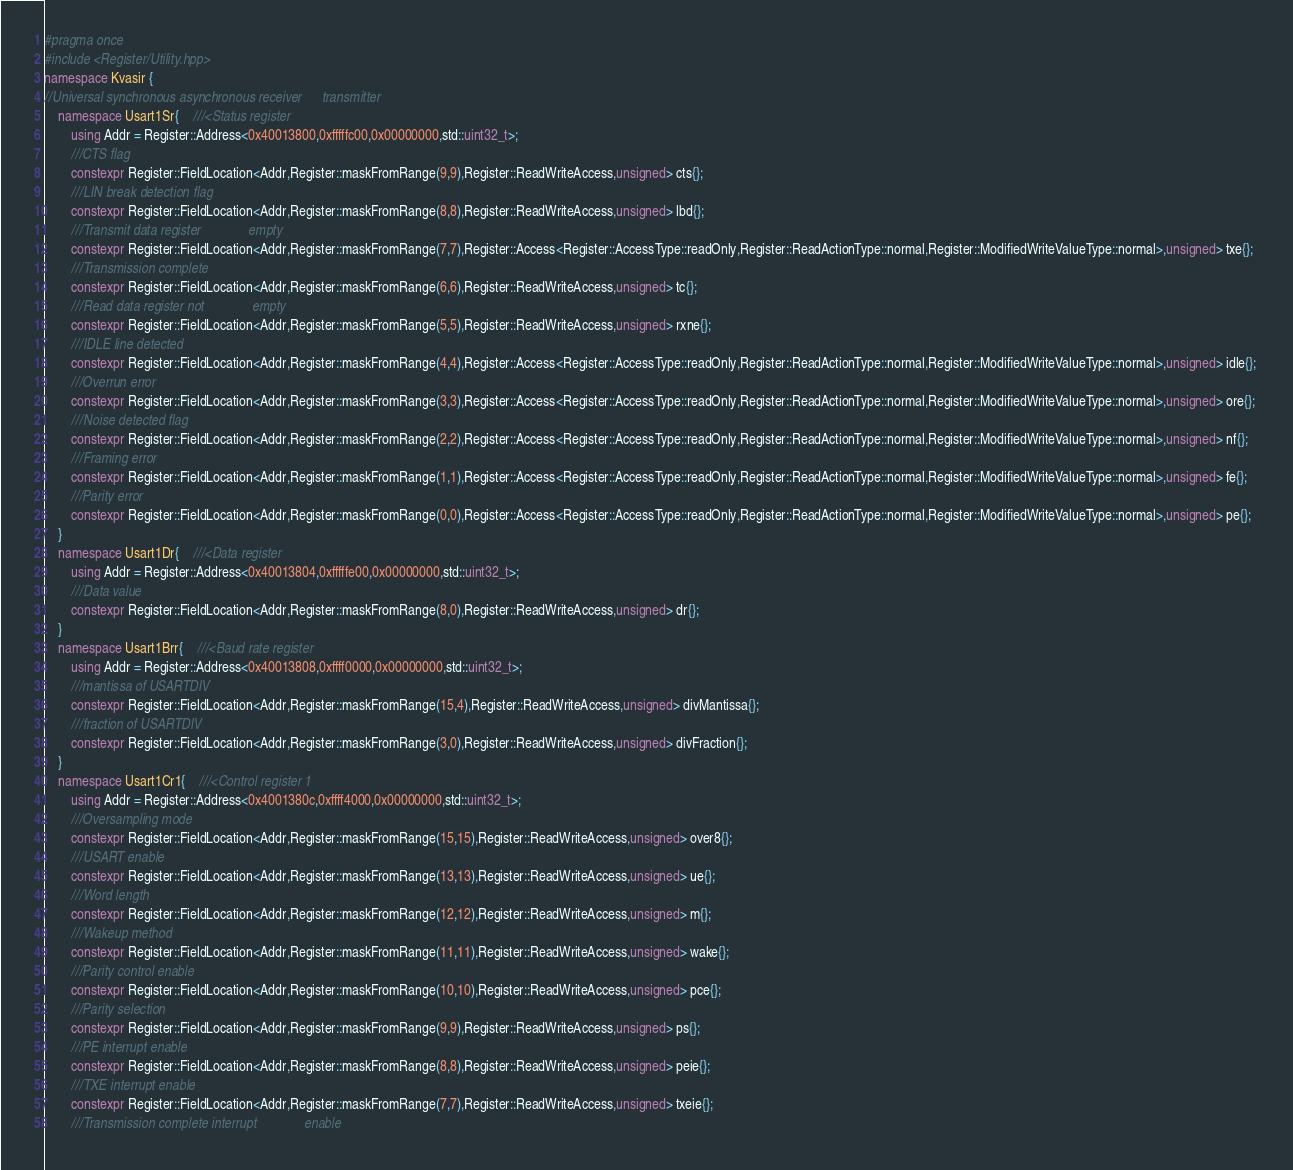Convert code to text. <code><loc_0><loc_0><loc_500><loc_500><_C++_>#pragma once 
#include <Register/Utility.hpp>
namespace Kvasir {
//Universal synchronous asynchronous receiver      transmitter
    namespace Usart1Sr{    ///<Status register
        using Addr = Register::Address<0x40013800,0xfffffc00,0x00000000,std::uint32_t>;
        ///CTS flag
        constexpr Register::FieldLocation<Addr,Register::maskFromRange(9,9),Register::ReadWriteAccess,unsigned> cts{}; 
        ///LIN break detection flag
        constexpr Register::FieldLocation<Addr,Register::maskFromRange(8,8),Register::ReadWriteAccess,unsigned> lbd{}; 
        ///Transmit data register              empty
        constexpr Register::FieldLocation<Addr,Register::maskFromRange(7,7),Register::Access<Register::AccessType::readOnly,Register::ReadActionType::normal,Register::ModifiedWriteValueType::normal>,unsigned> txe{}; 
        ///Transmission complete
        constexpr Register::FieldLocation<Addr,Register::maskFromRange(6,6),Register::ReadWriteAccess,unsigned> tc{}; 
        ///Read data register not              empty
        constexpr Register::FieldLocation<Addr,Register::maskFromRange(5,5),Register::ReadWriteAccess,unsigned> rxne{}; 
        ///IDLE line detected
        constexpr Register::FieldLocation<Addr,Register::maskFromRange(4,4),Register::Access<Register::AccessType::readOnly,Register::ReadActionType::normal,Register::ModifiedWriteValueType::normal>,unsigned> idle{}; 
        ///Overrun error
        constexpr Register::FieldLocation<Addr,Register::maskFromRange(3,3),Register::Access<Register::AccessType::readOnly,Register::ReadActionType::normal,Register::ModifiedWriteValueType::normal>,unsigned> ore{}; 
        ///Noise detected flag
        constexpr Register::FieldLocation<Addr,Register::maskFromRange(2,2),Register::Access<Register::AccessType::readOnly,Register::ReadActionType::normal,Register::ModifiedWriteValueType::normal>,unsigned> nf{}; 
        ///Framing error
        constexpr Register::FieldLocation<Addr,Register::maskFromRange(1,1),Register::Access<Register::AccessType::readOnly,Register::ReadActionType::normal,Register::ModifiedWriteValueType::normal>,unsigned> fe{}; 
        ///Parity error
        constexpr Register::FieldLocation<Addr,Register::maskFromRange(0,0),Register::Access<Register::AccessType::readOnly,Register::ReadActionType::normal,Register::ModifiedWriteValueType::normal>,unsigned> pe{}; 
    }
    namespace Usart1Dr{    ///<Data register
        using Addr = Register::Address<0x40013804,0xfffffe00,0x00000000,std::uint32_t>;
        ///Data value
        constexpr Register::FieldLocation<Addr,Register::maskFromRange(8,0),Register::ReadWriteAccess,unsigned> dr{}; 
    }
    namespace Usart1Brr{    ///<Baud rate register
        using Addr = Register::Address<0x40013808,0xffff0000,0x00000000,std::uint32_t>;
        ///mantissa of USARTDIV
        constexpr Register::FieldLocation<Addr,Register::maskFromRange(15,4),Register::ReadWriteAccess,unsigned> divMantissa{}; 
        ///fraction of USARTDIV
        constexpr Register::FieldLocation<Addr,Register::maskFromRange(3,0),Register::ReadWriteAccess,unsigned> divFraction{}; 
    }
    namespace Usart1Cr1{    ///<Control register 1
        using Addr = Register::Address<0x4001380c,0xffff4000,0x00000000,std::uint32_t>;
        ///Oversampling mode
        constexpr Register::FieldLocation<Addr,Register::maskFromRange(15,15),Register::ReadWriteAccess,unsigned> over8{}; 
        ///USART enable
        constexpr Register::FieldLocation<Addr,Register::maskFromRange(13,13),Register::ReadWriteAccess,unsigned> ue{}; 
        ///Word length
        constexpr Register::FieldLocation<Addr,Register::maskFromRange(12,12),Register::ReadWriteAccess,unsigned> m{}; 
        ///Wakeup method
        constexpr Register::FieldLocation<Addr,Register::maskFromRange(11,11),Register::ReadWriteAccess,unsigned> wake{}; 
        ///Parity control enable
        constexpr Register::FieldLocation<Addr,Register::maskFromRange(10,10),Register::ReadWriteAccess,unsigned> pce{}; 
        ///Parity selection
        constexpr Register::FieldLocation<Addr,Register::maskFromRange(9,9),Register::ReadWriteAccess,unsigned> ps{}; 
        ///PE interrupt enable
        constexpr Register::FieldLocation<Addr,Register::maskFromRange(8,8),Register::ReadWriteAccess,unsigned> peie{}; 
        ///TXE interrupt enable
        constexpr Register::FieldLocation<Addr,Register::maskFromRange(7,7),Register::ReadWriteAccess,unsigned> txeie{}; 
        ///Transmission complete interrupt              enable</code> 